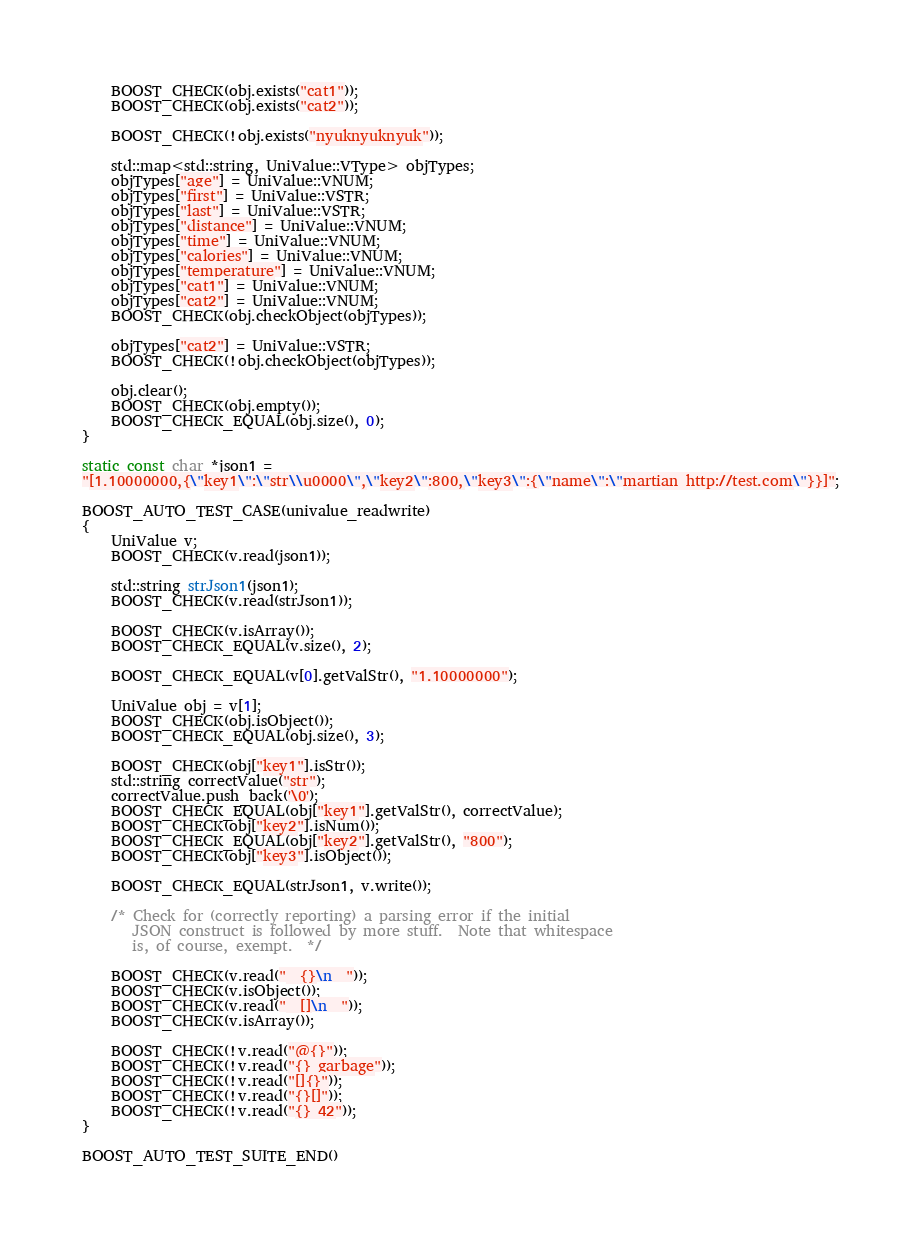<code> <loc_0><loc_0><loc_500><loc_500><_C++_>    BOOST_CHECK(obj.exists("cat1"));
    BOOST_CHECK(obj.exists("cat2"));

    BOOST_CHECK(!obj.exists("nyuknyuknyuk"));

    std::map<std::string, UniValue::VType> objTypes;
    objTypes["age"] = UniValue::VNUM;
    objTypes["first"] = UniValue::VSTR;
    objTypes["last"] = UniValue::VSTR;
    objTypes["distance"] = UniValue::VNUM;
    objTypes["time"] = UniValue::VNUM;
    objTypes["calories"] = UniValue::VNUM;
    objTypes["temperature"] = UniValue::VNUM;
    objTypes["cat1"] = UniValue::VNUM;
    objTypes["cat2"] = UniValue::VNUM;
    BOOST_CHECK(obj.checkObject(objTypes));

    objTypes["cat2"] = UniValue::VSTR;
    BOOST_CHECK(!obj.checkObject(objTypes));

    obj.clear();
    BOOST_CHECK(obj.empty());
    BOOST_CHECK_EQUAL(obj.size(), 0);
}

static const char *json1 =
"[1.10000000,{\"key1\":\"str\\u0000\",\"key2\":800,\"key3\":{\"name\":\"martian http://test.com\"}}]";

BOOST_AUTO_TEST_CASE(univalue_readwrite)
{
    UniValue v;
    BOOST_CHECK(v.read(json1));

    std::string strJson1(json1);
    BOOST_CHECK(v.read(strJson1));

    BOOST_CHECK(v.isArray());
    BOOST_CHECK_EQUAL(v.size(), 2);

    BOOST_CHECK_EQUAL(v[0].getValStr(), "1.10000000");

    UniValue obj = v[1];
    BOOST_CHECK(obj.isObject());
    BOOST_CHECK_EQUAL(obj.size(), 3);

    BOOST_CHECK(obj["key1"].isStr());
    std::string correctValue("str");
    correctValue.push_back('\0');
    BOOST_CHECK_EQUAL(obj["key1"].getValStr(), correctValue);
    BOOST_CHECK(obj["key2"].isNum());
    BOOST_CHECK_EQUAL(obj["key2"].getValStr(), "800");
    BOOST_CHECK(obj["key3"].isObject());

    BOOST_CHECK_EQUAL(strJson1, v.write());

    /* Check for (correctly reporting) a parsing error if the initial
       JSON construct is followed by more stuff.  Note that whitespace
       is, of course, exempt.  */

    BOOST_CHECK(v.read("  {}\n  "));
    BOOST_CHECK(v.isObject());
    BOOST_CHECK(v.read("  []\n  "));
    BOOST_CHECK(v.isArray());

    BOOST_CHECK(!v.read("@{}"));
    BOOST_CHECK(!v.read("{} garbage"));
    BOOST_CHECK(!v.read("[]{}"));
    BOOST_CHECK(!v.read("{}[]"));
    BOOST_CHECK(!v.read("{} 42"));
}

BOOST_AUTO_TEST_SUITE_END()
</code> 